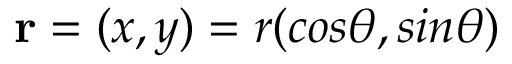<formula> <loc_0><loc_0><loc_500><loc_500>{ r } = ( x , y ) = r ( \cos \theta , \sin \theta )</formula> 